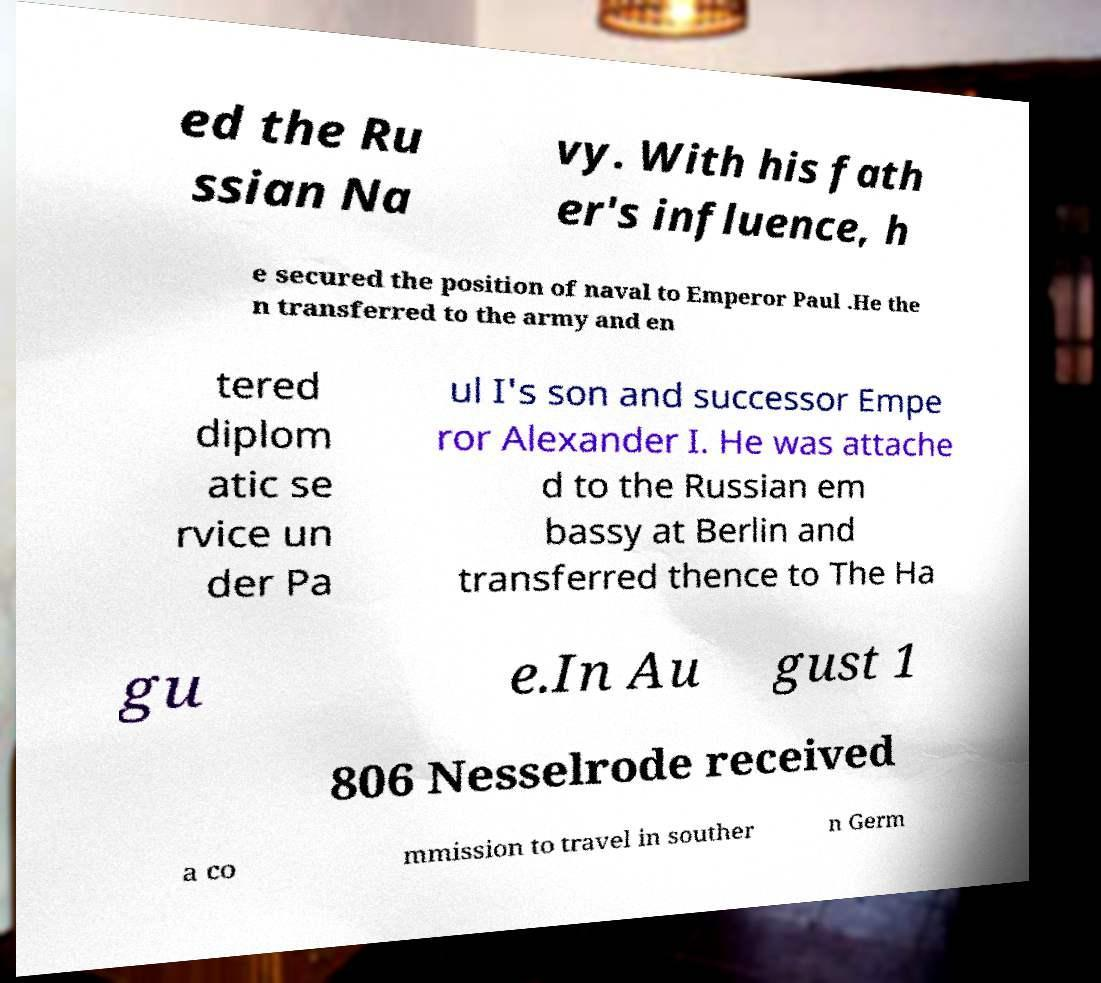Could you extract and type out the text from this image? ed the Ru ssian Na vy. With his fath er's influence, h e secured the position of naval to Emperor Paul .He the n transferred to the army and en tered diplom atic se rvice un der Pa ul I's son and successor Empe ror Alexander I. He was attache d to the Russian em bassy at Berlin and transferred thence to The Ha gu e.In Au gust 1 806 Nesselrode received a co mmission to travel in souther n Germ 